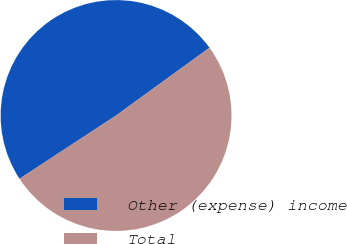Convert chart to OTSL. <chart><loc_0><loc_0><loc_500><loc_500><pie_chart><fcel>Other (expense) income<fcel>Total<nl><fcel>49.25%<fcel>50.75%<nl></chart> 